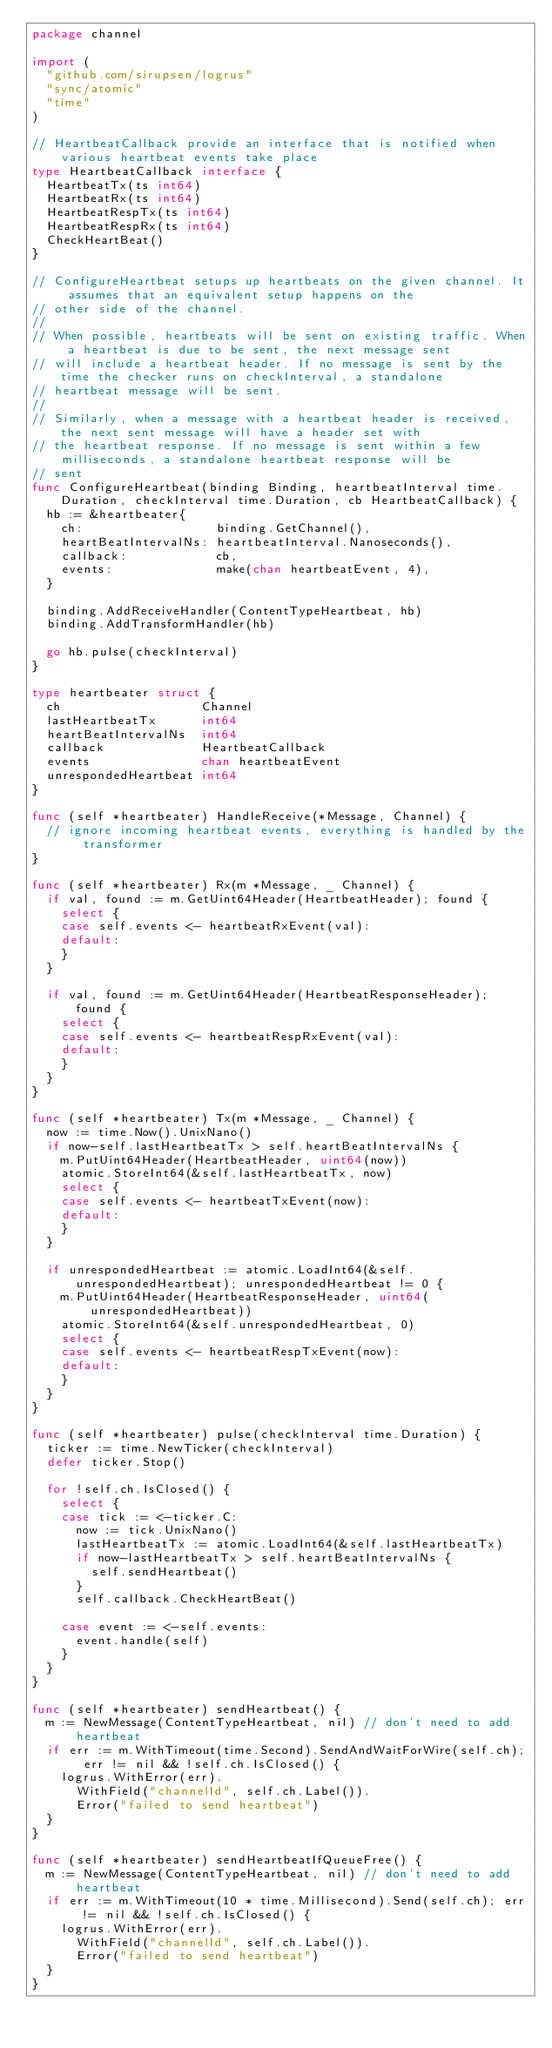Convert code to text. <code><loc_0><loc_0><loc_500><loc_500><_Go_>package channel

import (
	"github.com/sirupsen/logrus"
	"sync/atomic"
	"time"
)

// HeartbeatCallback provide an interface that is notified when various heartbeat events take place
type HeartbeatCallback interface {
	HeartbeatTx(ts int64)
	HeartbeatRx(ts int64)
	HeartbeatRespTx(ts int64)
	HeartbeatRespRx(ts int64)
	CheckHeartBeat()
}

// ConfigureHeartbeat setups up heartbeats on the given channel. It assumes that an equivalent setup happens on the
// other side of the channel.
//
// When possible, heartbeats will be sent on existing traffic. When a heartbeat is due to be sent, the next message sent
// will include a heartbeat header. If no message is sent by the time the checker runs on checkInterval, a standalone
// heartbeat message will be sent.
//
// Similarly, when a message with a heartbeat header is received, the next sent message will have a header set with
// the heartbeat response. If no message is sent within a few milliseconds, a standalone heartbeat response will be
// sent
func ConfigureHeartbeat(binding Binding, heartbeatInterval time.Duration, checkInterval time.Duration, cb HeartbeatCallback) {
	hb := &heartbeater{
		ch:                  binding.GetChannel(),
		heartBeatIntervalNs: heartbeatInterval.Nanoseconds(),
		callback:            cb,
		events:              make(chan heartbeatEvent, 4),
	}

	binding.AddReceiveHandler(ContentTypeHeartbeat, hb)
	binding.AddTransformHandler(hb)

	go hb.pulse(checkInterval)
}

type heartbeater struct {
	ch                   Channel
	lastHeartbeatTx      int64
	heartBeatIntervalNs  int64
	callback             HeartbeatCallback
	events               chan heartbeatEvent
	unrespondedHeartbeat int64
}

func (self *heartbeater) HandleReceive(*Message, Channel) {
	// ignore incoming heartbeat events, everything is handled by the transformer
}

func (self *heartbeater) Rx(m *Message, _ Channel) {
	if val, found := m.GetUint64Header(HeartbeatHeader); found {
		select {
		case self.events <- heartbeatRxEvent(val):
		default:
		}
	}

	if val, found := m.GetUint64Header(HeartbeatResponseHeader); found {
		select {
		case self.events <- heartbeatRespRxEvent(val):
		default:
		}
	}
}

func (self *heartbeater) Tx(m *Message, _ Channel) {
	now := time.Now().UnixNano()
	if now-self.lastHeartbeatTx > self.heartBeatIntervalNs {
		m.PutUint64Header(HeartbeatHeader, uint64(now))
		atomic.StoreInt64(&self.lastHeartbeatTx, now)
		select {
		case self.events <- heartbeatTxEvent(now):
		default:
		}
	}

	if unrespondedHeartbeat := atomic.LoadInt64(&self.unrespondedHeartbeat); unrespondedHeartbeat != 0 {
		m.PutUint64Header(HeartbeatResponseHeader, uint64(unrespondedHeartbeat))
		atomic.StoreInt64(&self.unrespondedHeartbeat, 0)
		select {
		case self.events <- heartbeatRespTxEvent(now):
		default:
		}
	}
}

func (self *heartbeater) pulse(checkInterval time.Duration) {
	ticker := time.NewTicker(checkInterval)
	defer ticker.Stop()

	for !self.ch.IsClosed() {
		select {
		case tick := <-ticker.C:
			now := tick.UnixNano()
			lastHeartbeatTx := atomic.LoadInt64(&self.lastHeartbeatTx)
			if now-lastHeartbeatTx > self.heartBeatIntervalNs {
				self.sendHeartbeat()
			}
			self.callback.CheckHeartBeat()

		case event := <-self.events:
			event.handle(self)
		}
	}
}

func (self *heartbeater) sendHeartbeat() {
	m := NewMessage(ContentTypeHeartbeat, nil) // don't need to add heartbeat
	if err := m.WithTimeout(time.Second).SendAndWaitForWire(self.ch); err != nil && !self.ch.IsClosed() {
		logrus.WithError(err).
			WithField("channelId", self.ch.Label()).
			Error("failed to send heartbeat")
	}
}

func (self *heartbeater) sendHeartbeatIfQueueFree() {
	m := NewMessage(ContentTypeHeartbeat, nil) // don't need to add heartbeat
	if err := m.WithTimeout(10 * time.Millisecond).Send(self.ch); err != nil && !self.ch.IsClosed() {
		logrus.WithError(err).
			WithField("channelId", self.ch.Label()).
			Error("failed to send heartbeat")
	}
}
</code> 